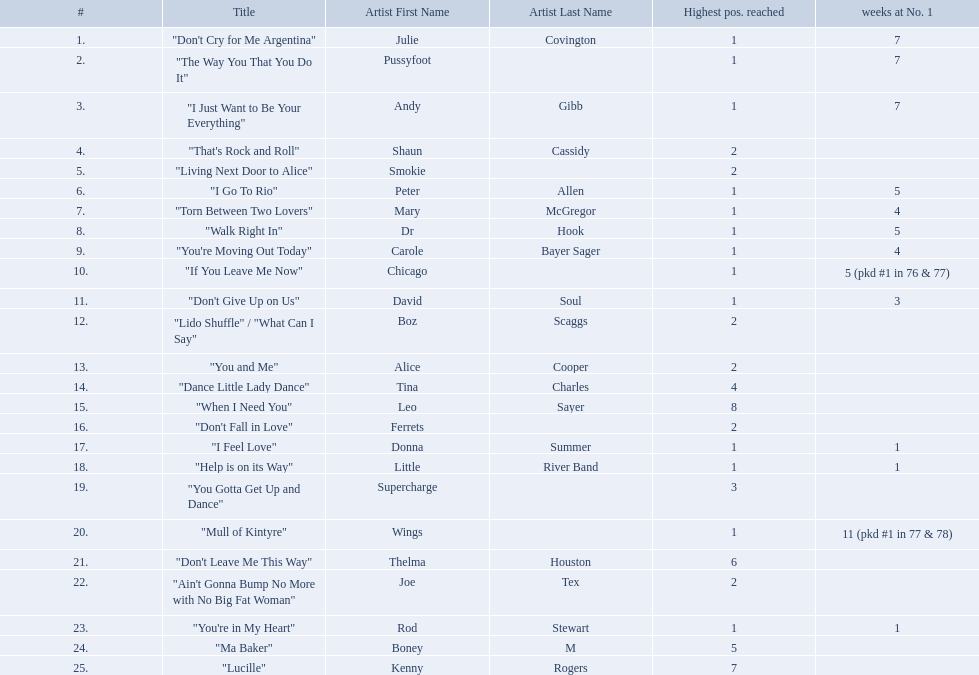How long is the longest amount of time spent at number 1? 11 (pkd #1 in 77 & 78). What song spent 11 weeks at number 1? "Mull of Kintyre". What band had a number 1 hit with this song? Wings. Who had the one of the least weeks at number one? Rod Stewart. Who had no week at number one? Shaun Cassidy. Who had the highest number of weeks at number one? Wings. 